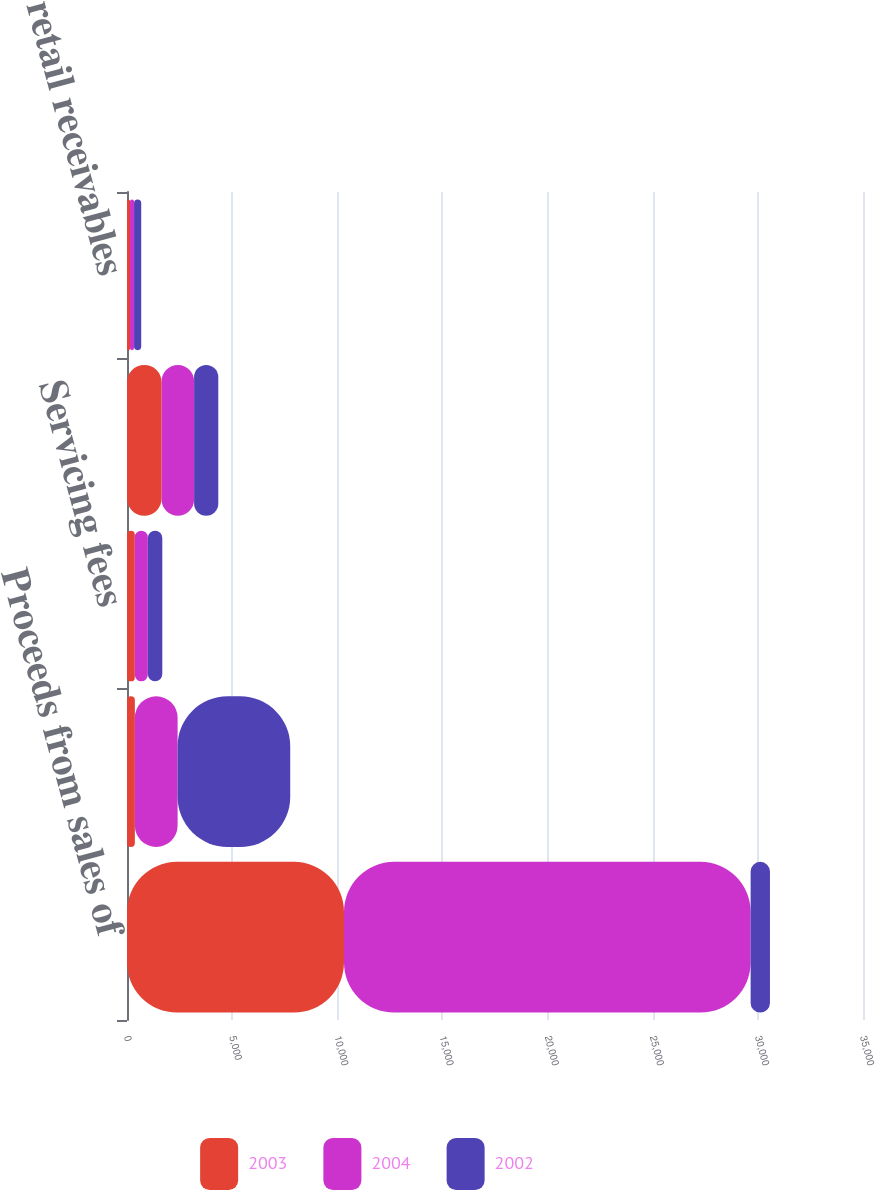<chart> <loc_0><loc_0><loc_500><loc_500><stacked_bar_chart><ecel><fcel>Proceeds from sales of<fcel>Net change in retained<fcel>Servicing fees<fcel>Interest on retained<fcel>Repurchased retail receivables<nl><fcel>2003<fcel>10319<fcel>374<fcel>372<fcel>1646<fcel>143<nl><fcel>2004<fcel>19337<fcel>2033<fcel>618<fcel>1545<fcel>193<nl><fcel>2002<fcel>919.5<fcel>5355<fcel>689<fcel>1150<fcel>340<nl></chart> 